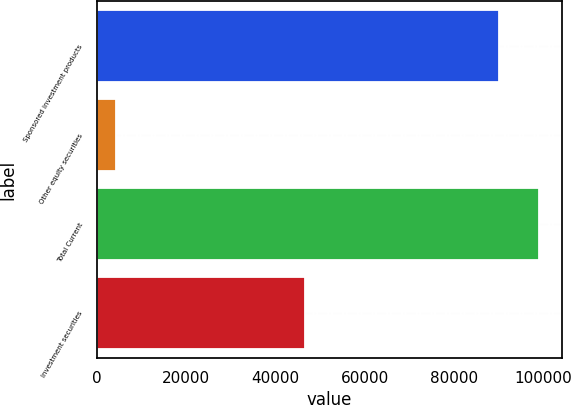<chart> <loc_0><loc_0><loc_500><loc_500><bar_chart><fcel>Sponsored investment products<fcel>Other equity securities<fcel>Total Current<fcel>Investment securities<nl><fcel>90210<fcel>4200<fcel>99231<fcel>46713<nl></chart> 